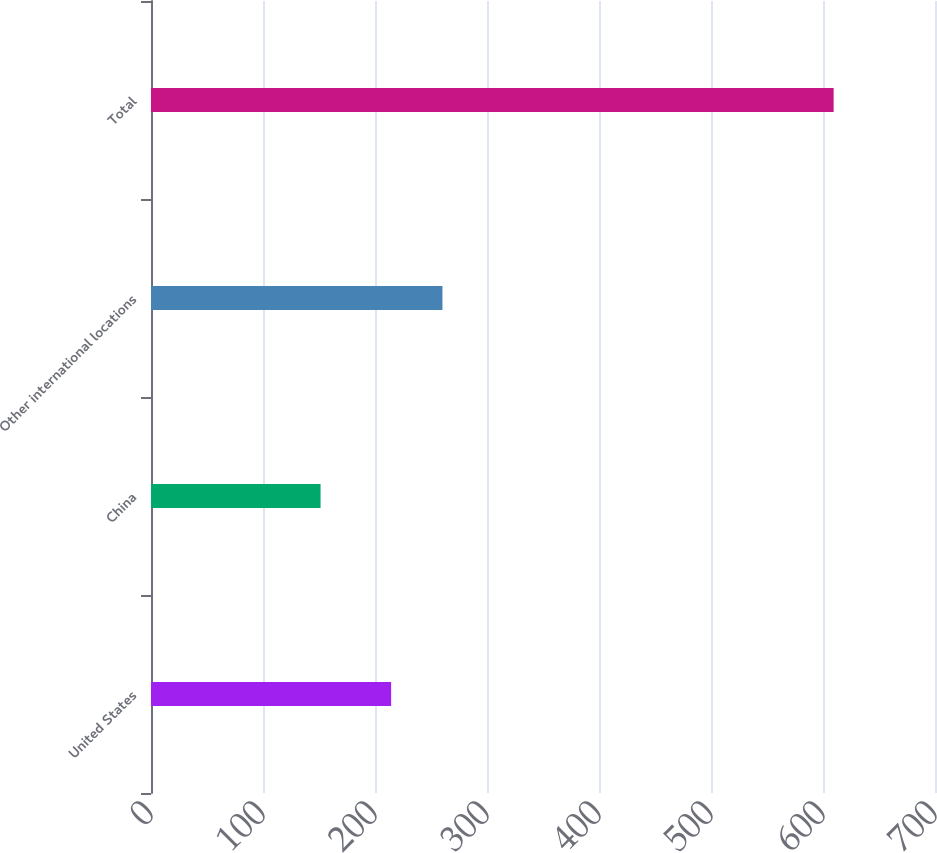Convert chart to OTSL. <chart><loc_0><loc_0><loc_500><loc_500><bar_chart><fcel>United States<fcel>China<fcel>Other international locations<fcel>Total<nl><fcel>214.4<fcel>151.4<fcel>260.21<fcel>609.5<nl></chart> 